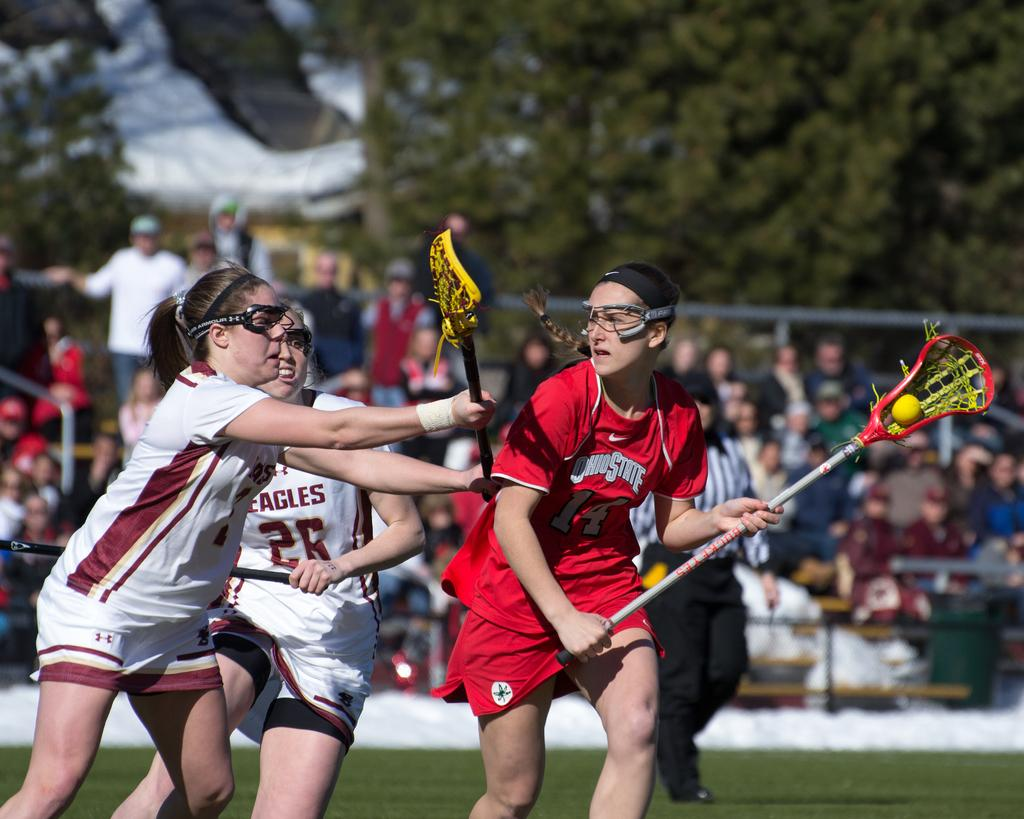Provide a one-sentence caption for the provided image. the team in white jersey is the Eagles. 